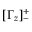Convert formula to latex. <formula><loc_0><loc_0><loc_500><loc_500>[ \Gamma _ { z } ] _ { - } ^ { + }</formula> 